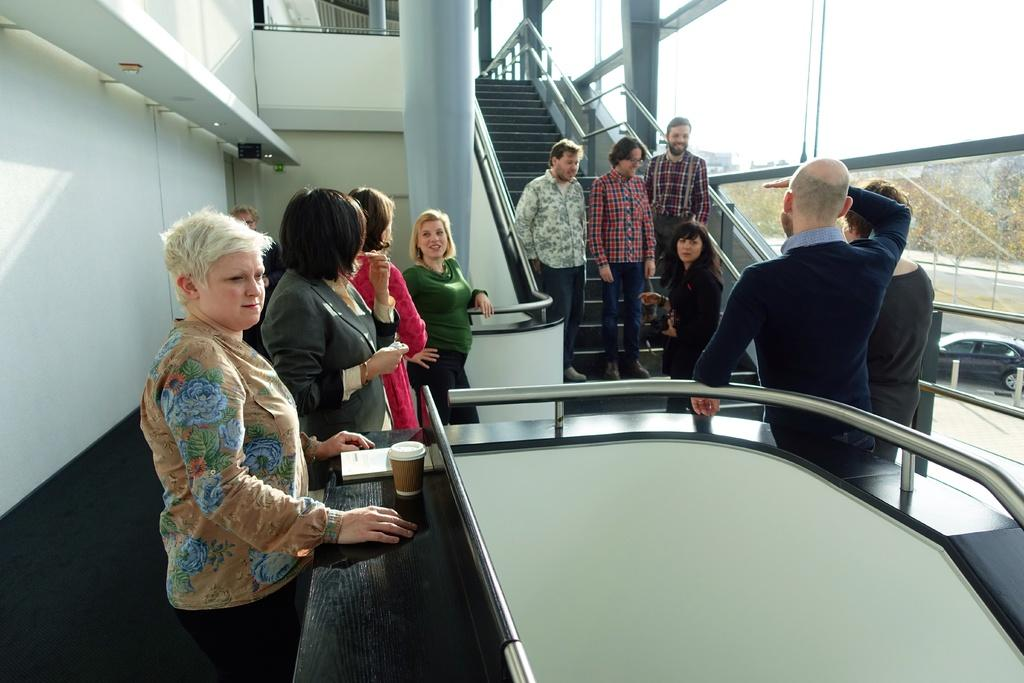How many people are visible in the image? There are people standing in the image, but the exact number cannot be determined from the provided facts. What is on the table in the image? There is a glass object and a book on the table in the image. What is the purpose of the pillar in the image? The purpose of the pillar in the image cannot be determined from the provided facts. What can be seen through the glass objects in the image? Trees and the sky are visible through the glass in the image. Can you tell me how many cups are on the table in the image? There is no mention of cups in the provided facts, so we cannot determine the number of cups on the table. What type of comfort can be found in the image? The provided facts do not mention any aspect of comfort, so we cannot determine what type of comfort might be present in the image. 